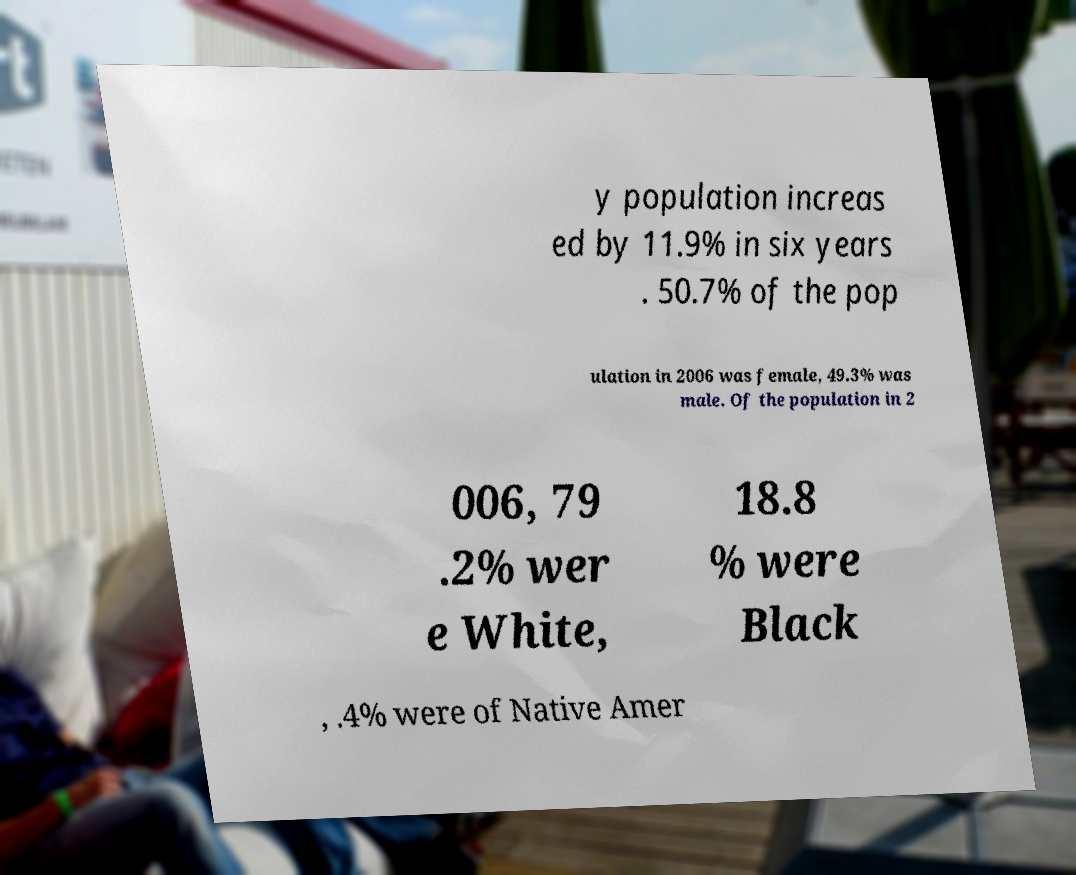I need the written content from this picture converted into text. Can you do that? y population increas ed by 11.9% in six years . 50.7% of the pop ulation in 2006 was female, 49.3% was male. Of the population in 2 006, 79 .2% wer e White, 18.8 % were Black , .4% were of Native Amer 